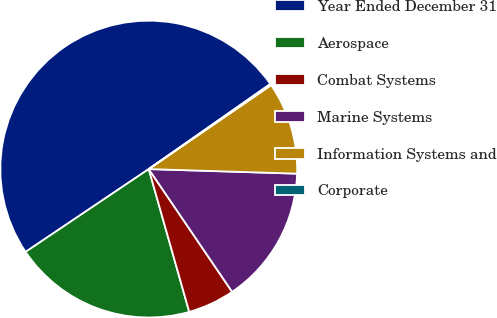Convert chart to OTSL. <chart><loc_0><loc_0><loc_500><loc_500><pie_chart><fcel>Year Ended December 31<fcel>Aerospace<fcel>Combat Systems<fcel>Marine Systems<fcel>Information Systems and<fcel>Corporate<nl><fcel>49.7%<fcel>19.97%<fcel>5.1%<fcel>15.01%<fcel>10.06%<fcel>0.15%<nl></chart> 